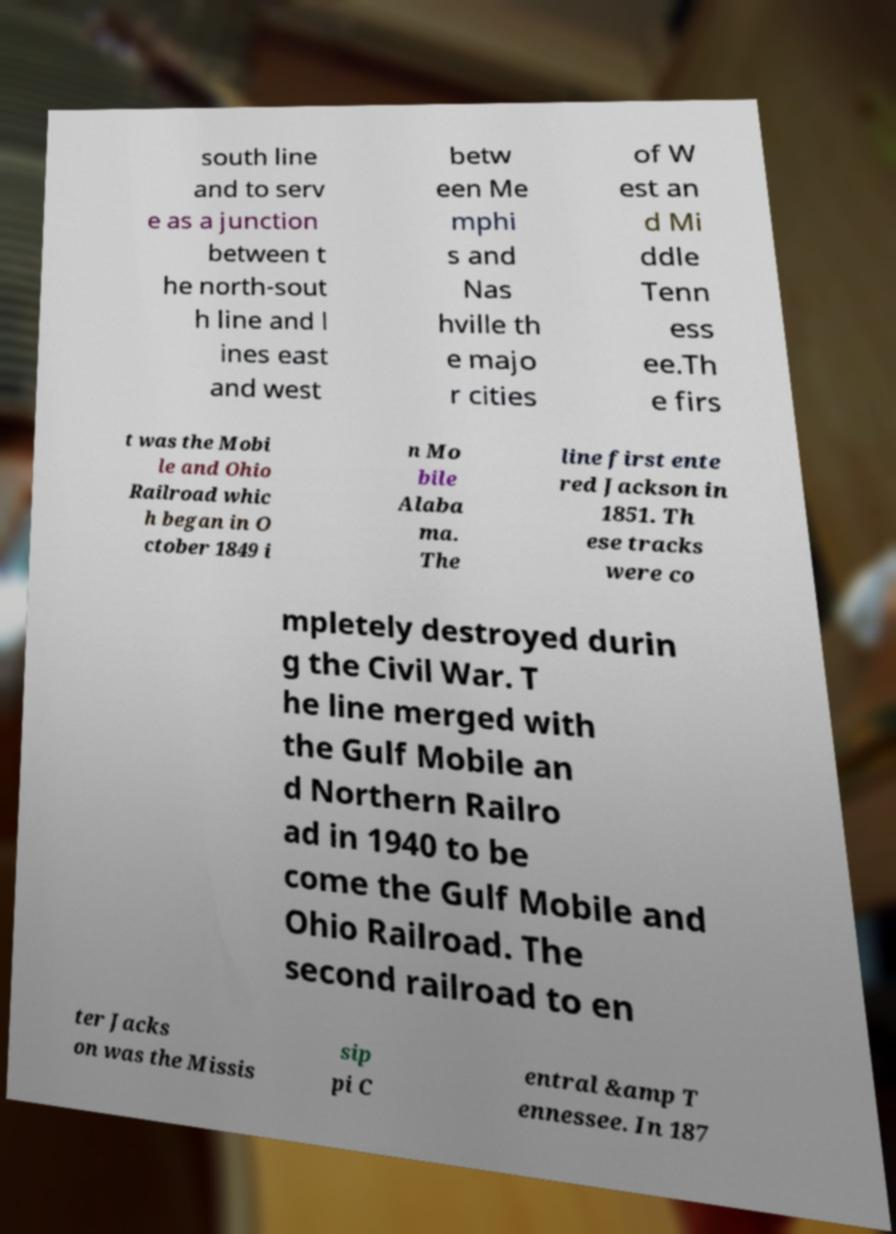Please read and relay the text visible in this image. What does it say? south line and to serv e as a junction between t he north-sout h line and l ines east and west betw een Me mphi s and Nas hville th e majo r cities of W est an d Mi ddle Tenn ess ee.Th e firs t was the Mobi le and Ohio Railroad whic h began in O ctober 1849 i n Mo bile Alaba ma. The line first ente red Jackson in 1851. Th ese tracks were co mpletely destroyed durin g the Civil War. T he line merged with the Gulf Mobile an d Northern Railro ad in 1940 to be come the Gulf Mobile and Ohio Railroad. The second railroad to en ter Jacks on was the Missis sip pi C entral &amp T ennessee. In 187 